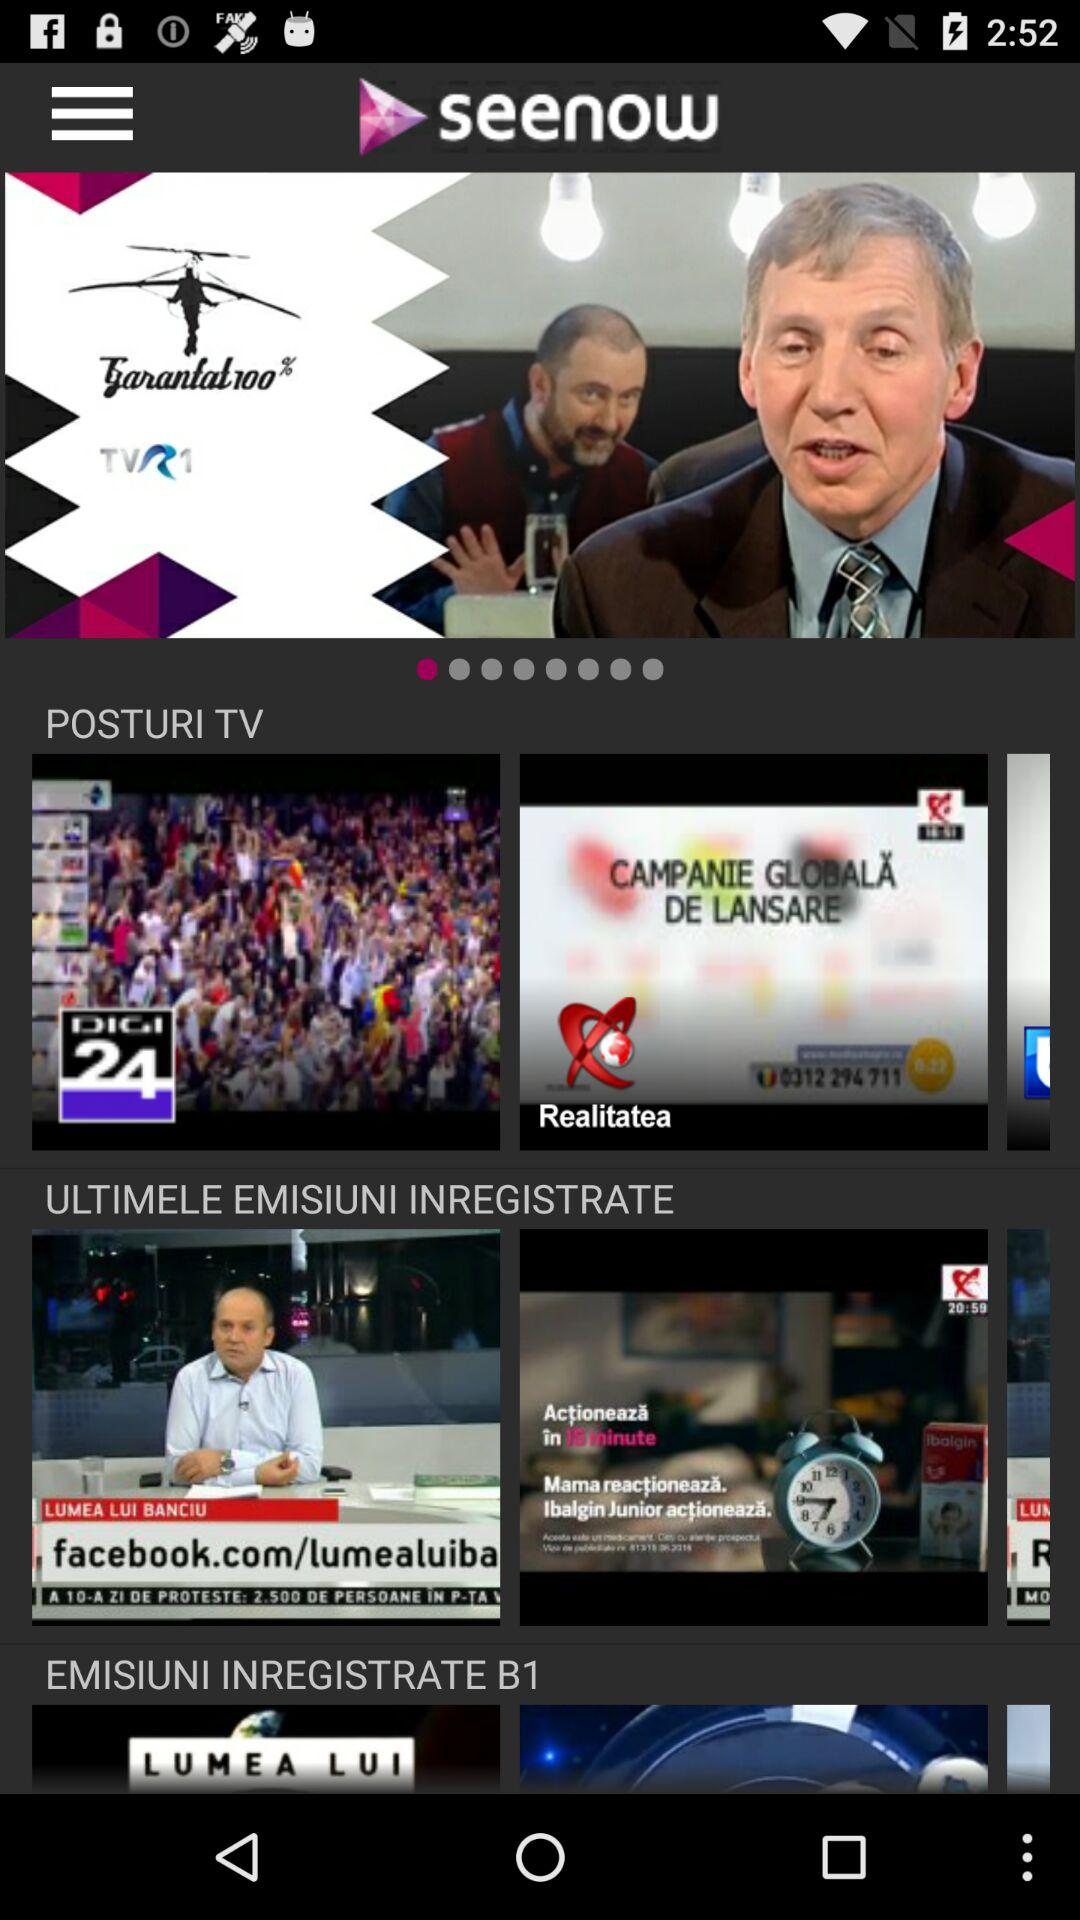What is the application name? The application name is "seenow". 